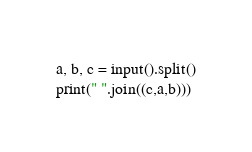<code> <loc_0><loc_0><loc_500><loc_500><_Python_>a, b, c = input().split()
print(" ".join((c,a,b)))</code> 